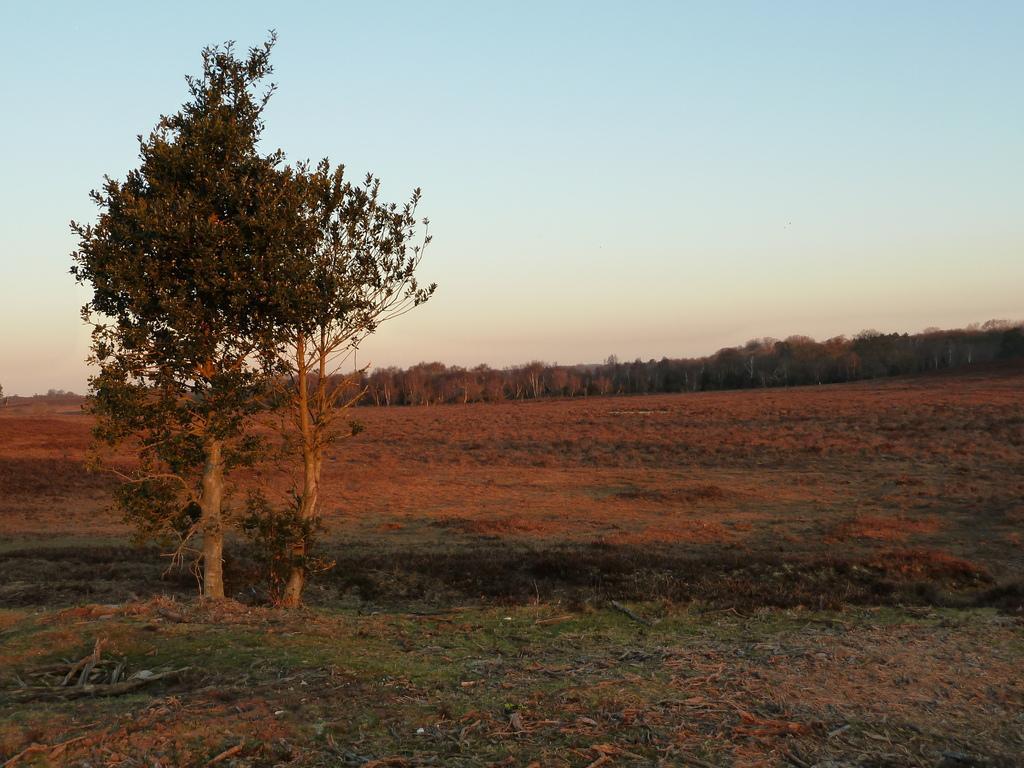In one or two sentences, can you explain what this image depicts? At the bottom, we see the grass, dry leaves and twigs. On the left side, we see a tree. There are trees in the background. At the top, we see the sky. 